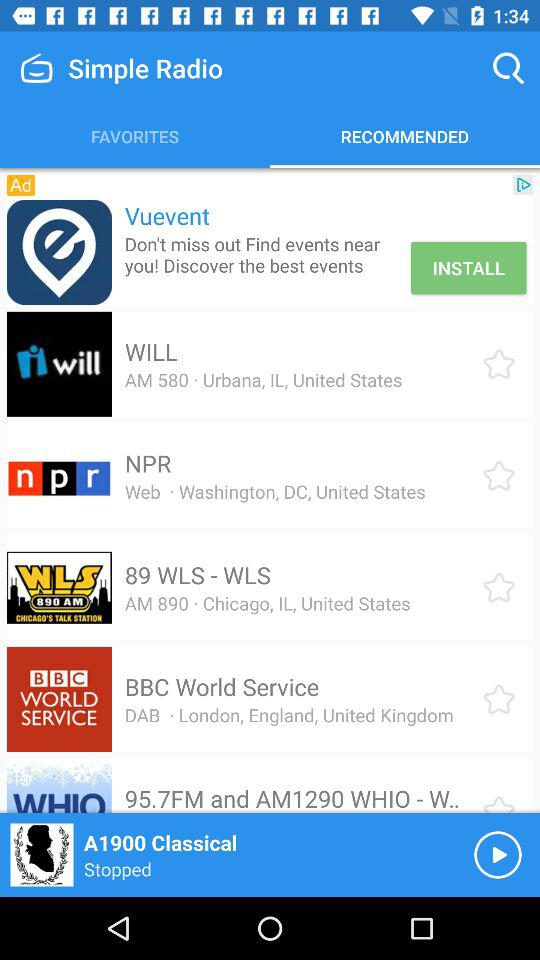What is the address of "WILL" radio? The address of "WILL" radio is Urbana, IL, United States. 